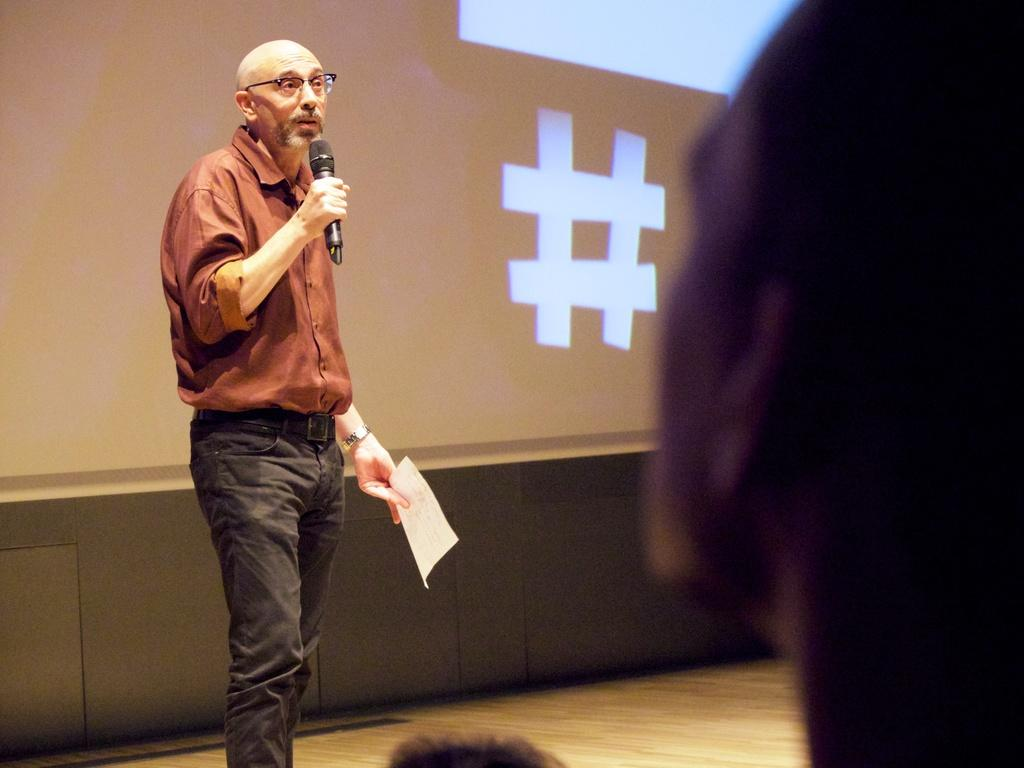What is the main subject of the image? The main subject of the image is a man. What is the man doing in the image? The man is standing in the image. What objects is the man holding in the image? The man is holding a microphone and a paper in his hands. What can be seen in the background of the image? There is a screen in the background of the image. How many planes are flying in the rainstorm depicted in the image? There is no rainstorm or planes present in the image; it features a man standing with a microphone and a paper. 